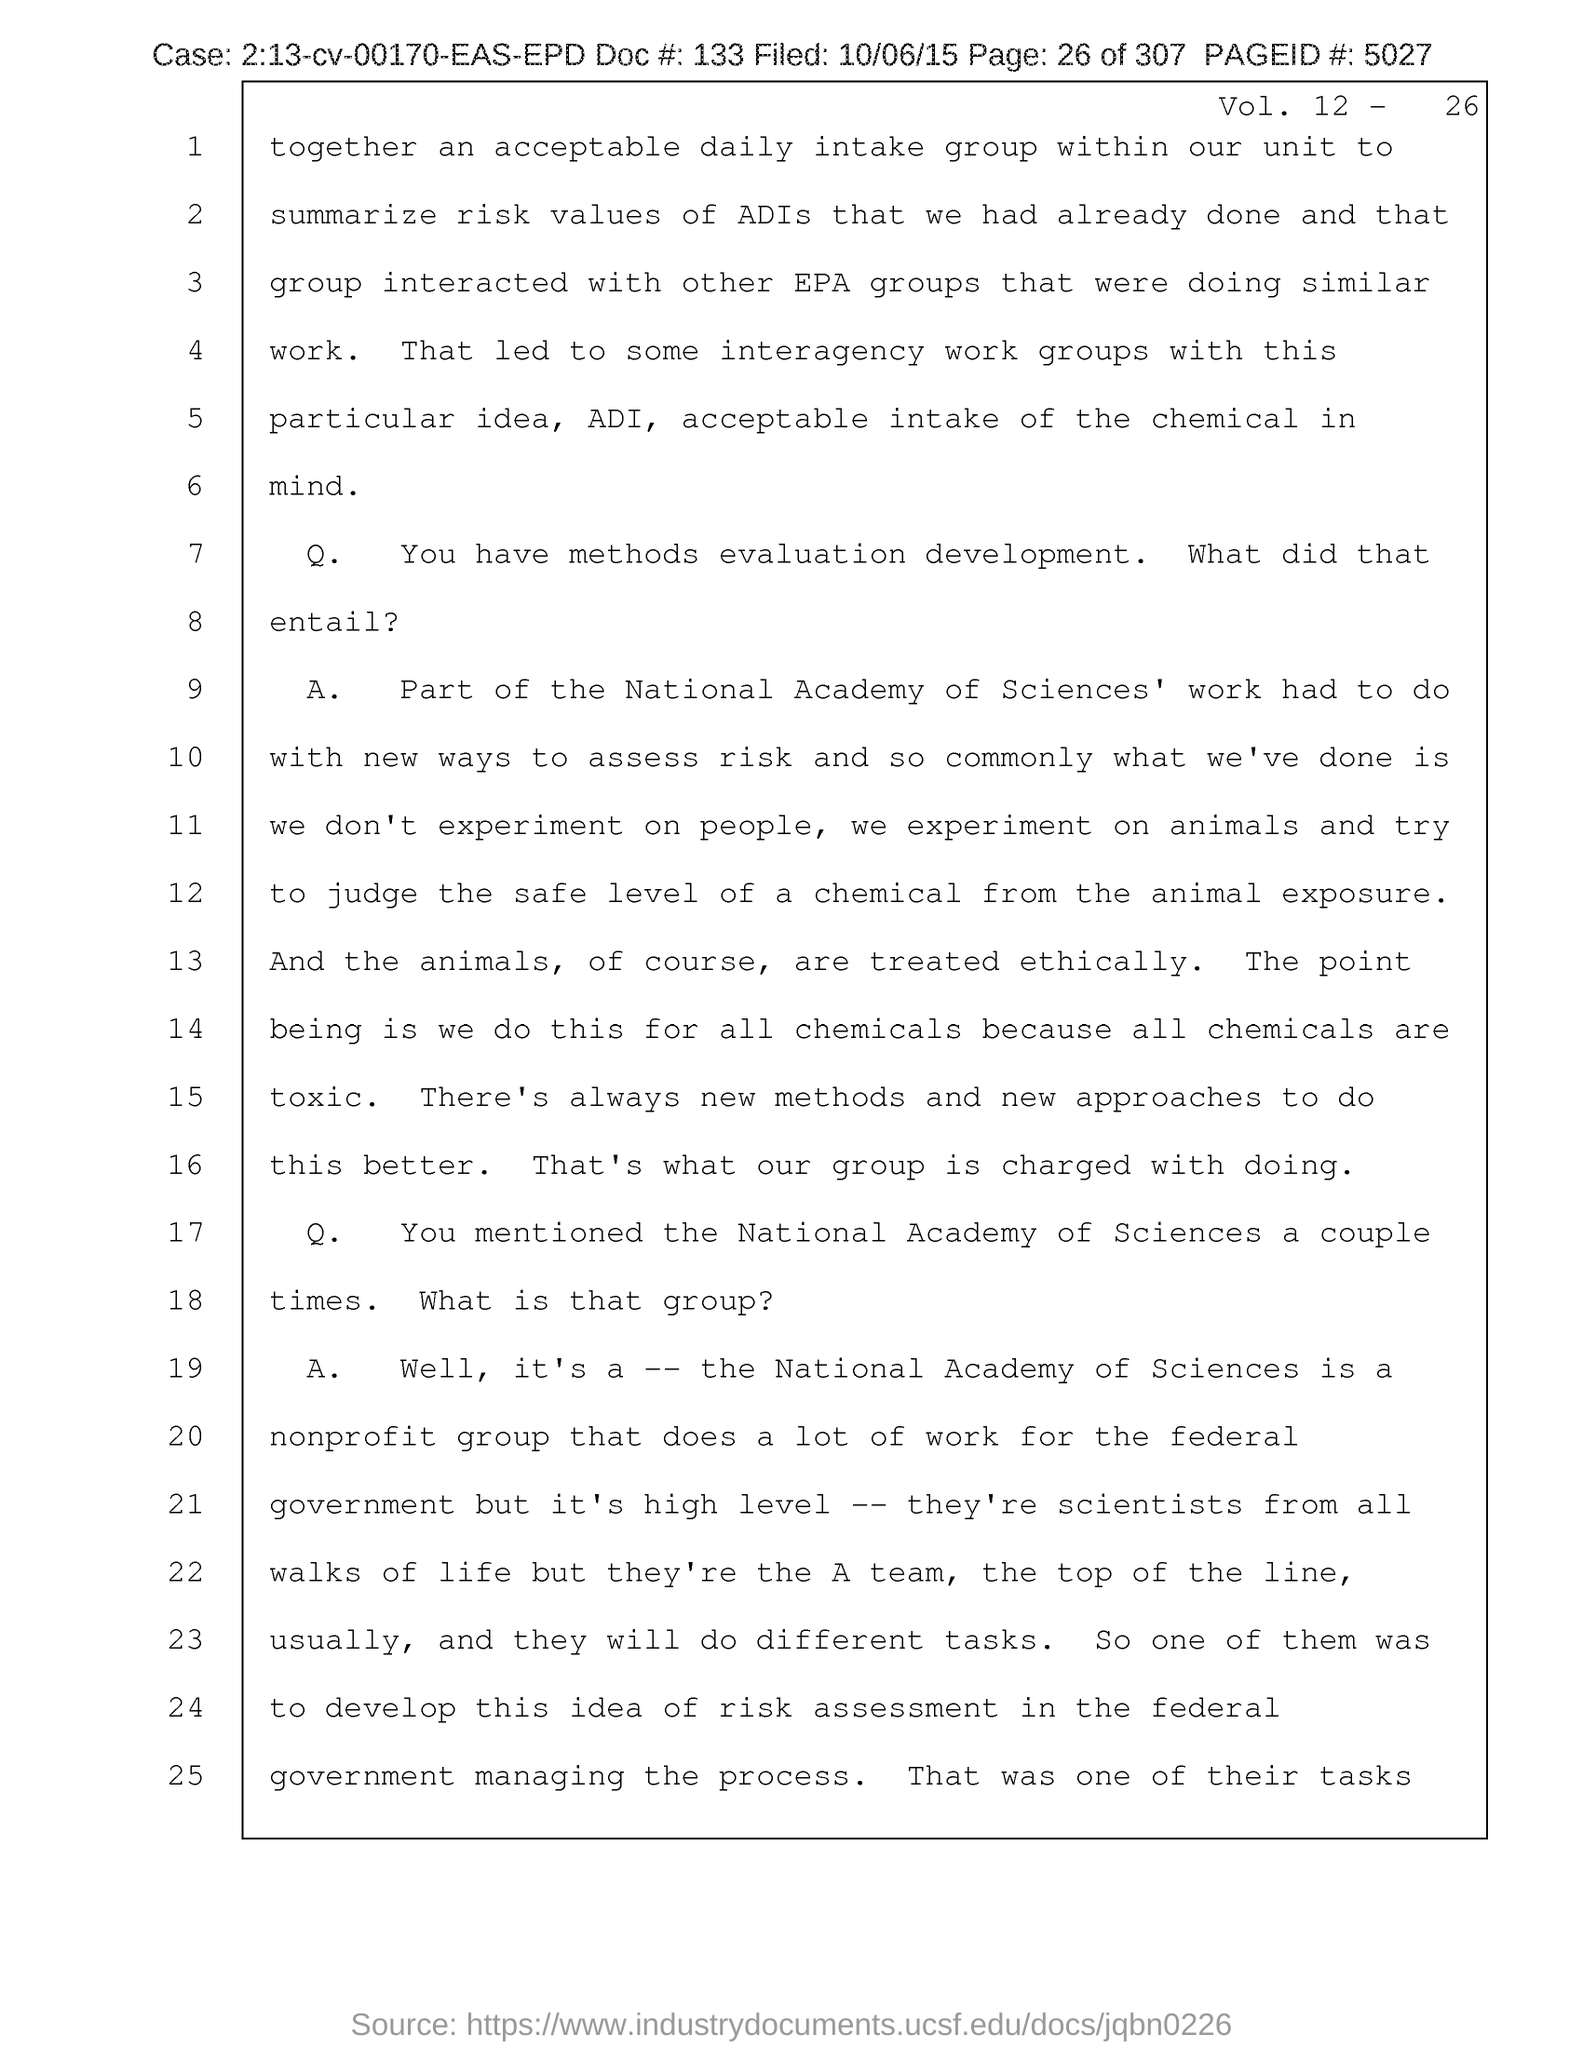Specify some key components in this picture. The page number referenced in this document is 26. Please provide the document number 133... The field date of the document is October 6, 2015. What is the page number given in the document? It is 5027. What is the case number mentioned in the document? 2:13-cv-00170-EAS-EPD... 